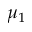Convert formula to latex. <formula><loc_0><loc_0><loc_500><loc_500>\mu _ { 1 }</formula> 